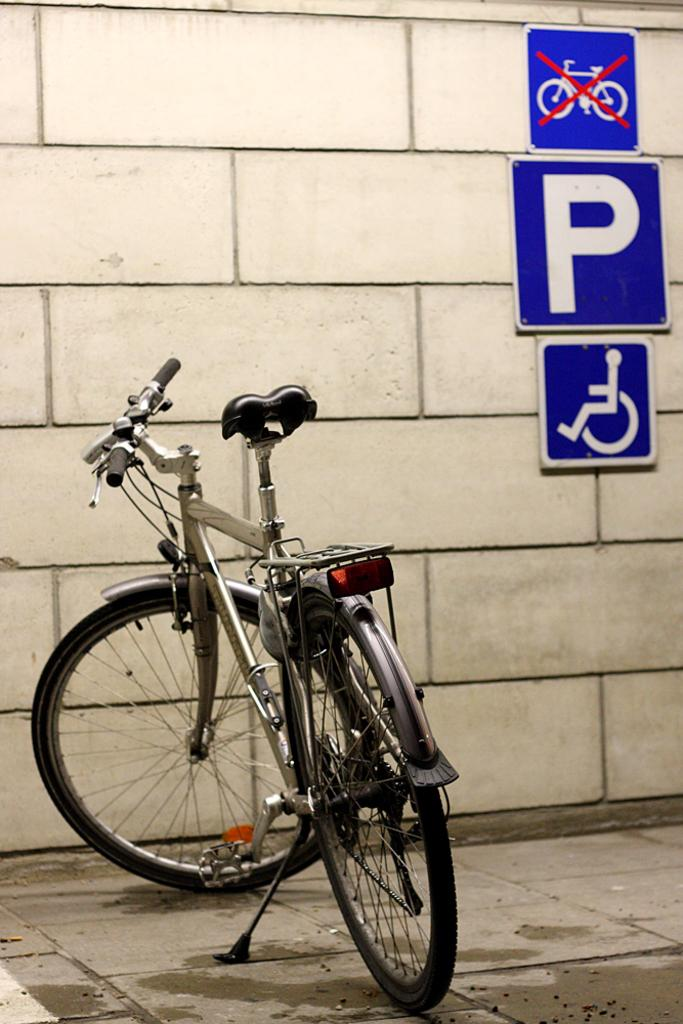What is the main subject in the center of the image? There is a cycle in the center of the image. What can be seen in the background of the image? There is a wall and sign boards in the background of the image. What type of shoes is the mind wearing in the image? There is no mind or shoes present in the image; it features a cycle and background elements. 